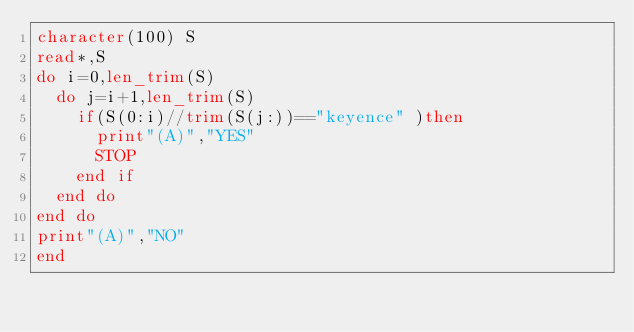<code> <loc_0><loc_0><loc_500><loc_500><_FORTRAN_>character(100) S
read*,S
do i=0,len_trim(S)
  do j=i+1,len_trim(S)
    if(S(0:i)//trim(S(j:))=="keyence" )then
      print"(A)","YES"
      STOP
    end if
  end do
end do
print"(A)","NO"
end</code> 